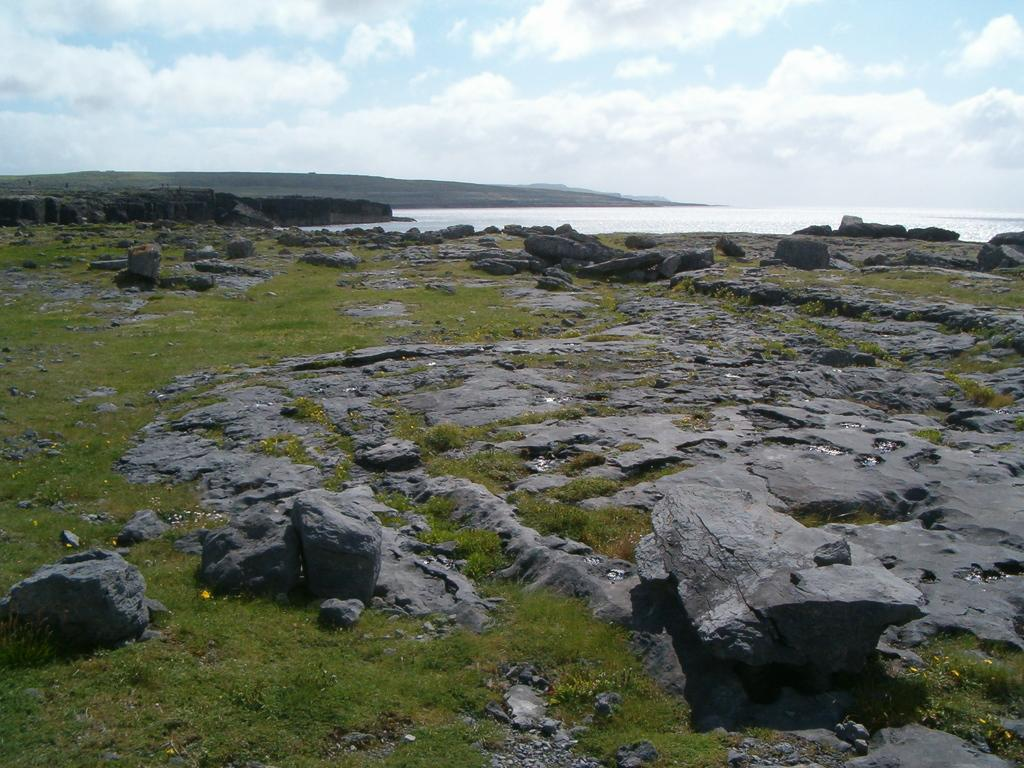What type of ground surface is visible in the image? There is green grass on the ground in the image. What other objects can be seen on the ground? Stones are visible in the image. What large body of water is present in the image? There is a sea in the image. What is visible at the top of the image? The sky is visible at the top of the image. What can be seen in the sky? There are clouds in the sky. What type of wine is being served at the beach in the image? There is no wine or beach present in the image; it features green grass, stones, a sea, and a sky with clouds. 